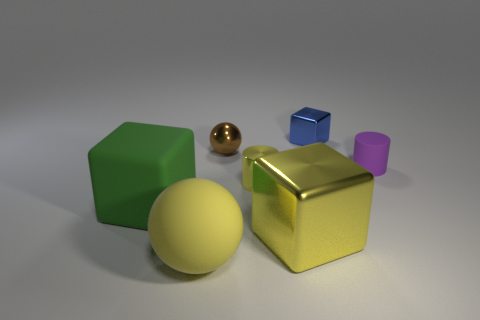Is there any source of light in the scene? You cannot see an explicit light source such as a lamp in the image, but the highlights and shadows on the objects suggest the light is coming from the upper left side, outside the field of view. This is evidenced by the reflections on the shiny objects and the shadows they cast toward the lower right. 